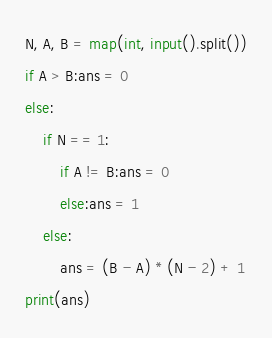Convert code to text. <code><loc_0><loc_0><loc_500><loc_500><_Python_>N, A, B = map(int, input().split())
if A > B:ans = 0
else:
    if N == 1:
        if A != B:ans = 0
        else:ans = 1
    else:
        ans = (B - A) * (N - 2) + 1
print(ans)</code> 